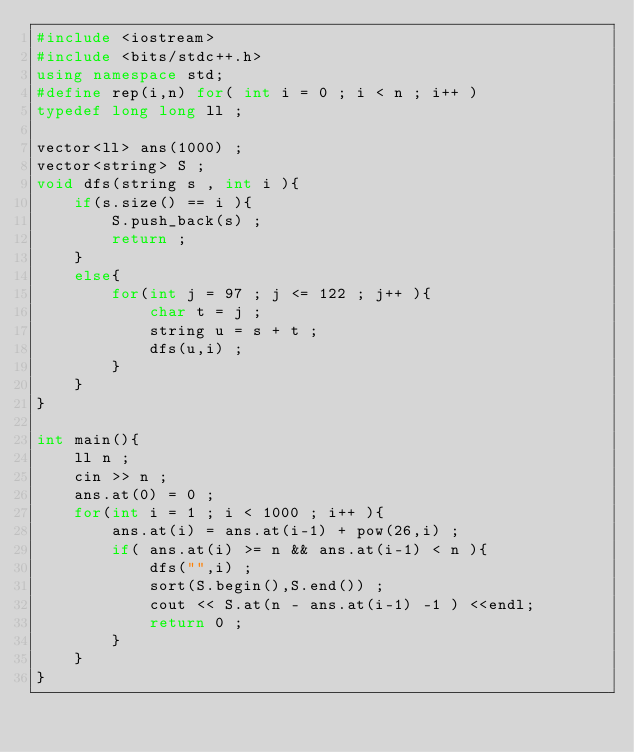<code> <loc_0><loc_0><loc_500><loc_500><_C++_>#include <iostream>
#include <bits/stdc++.h>
using namespace std;
#define rep(i,n) for( int i = 0 ; i < n ; i++ )
typedef long long ll ;

vector<ll> ans(1000) ;
vector<string> S ;
void dfs(string s , int i ){
    if(s.size() == i ){
        S.push_back(s) ; 
        return ; 
    } 
    else{
        for(int j = 97 ; j <= 122 ; j++ ){
            char t = j ;
            string u = s + t ;
            dfs(u,i) ;
        }
    }
}

int main(){
    ll n ;
    cin >> n ;
    ans.at(0) = 0 ;
    for(int i = 1 ; i < 1000 ; i++ ){
        ans.at(i) = ans.at(i-1) + pow(26,i) ;
        if( ans.at(i) >= n && ans.at(i-1) < n ){
            dfs("",i) ;
            sort(S.begin(),S.end()) ;
            cout << S.at(n - ans.at(i-1) -1 ) <<endl;
            return 0 ;
        }
    }
}

 </code> 